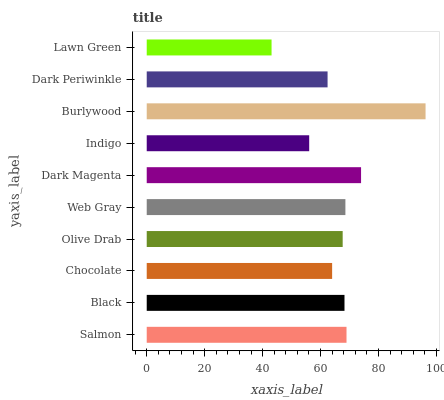Is Lawn Green the minimum?
Answer yes or no. Yes. Is Burlywood the maximum?
Answer yes or no. Yes. Is Black the minimum?
Answer yes or no. No. Is Black the maximum?
Answer yes or no. No. Is Salmon greater than Black?
Answer yes or no. Yes. Is Black less than Salmon?
Answer yes or no. Yes. Is Black greater than Salmon?
Answer yes or no. No. Is Salmon less than Black?
Answer yes or no. No. Is Black the high median?
Answer yes or no. Yes. Is Olive Drab the low median?
Answer yes or no. Yes. Is Salmon the high median?
Answer yes or no. No. Is Salmon the low median?
Answer yes or no. No. 